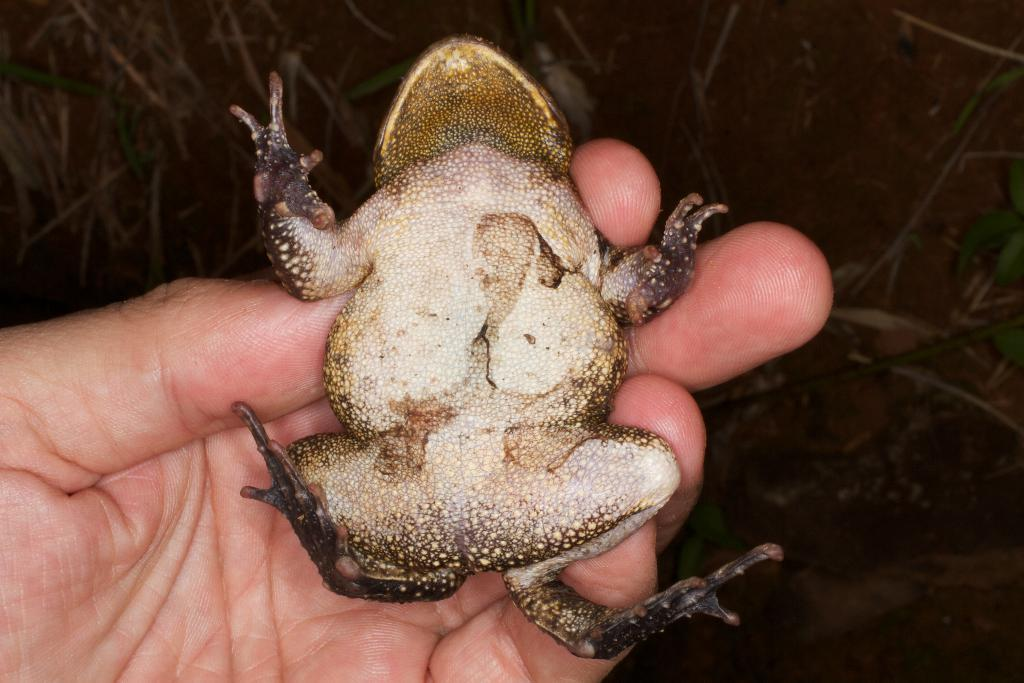What is the main subject in the foreground of the image? There is a frog in the foreground of the image. What is the person in the image doing with the frog? A person is holding the frog. What type of natural environment can be seen in the background of the image? There is grass and plants in the background of the image. How far does the frog need to travel to claim its territory in the image? There is no indication in the image that the frog is attempting to claim a territory, and therefore the distance cannot be determined. 